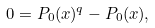<formula> <loc_0><loc_0><loc_500><loc_500>0 = P _ { 0 } ( x ) ^ { q } - P _ { 0 } ( x ) ,</formula> 